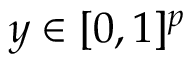<formula> <loc_0><loc_0><loc_500><loc_500>y \in [ 0 , 1 ] ^ { p }</formula> 